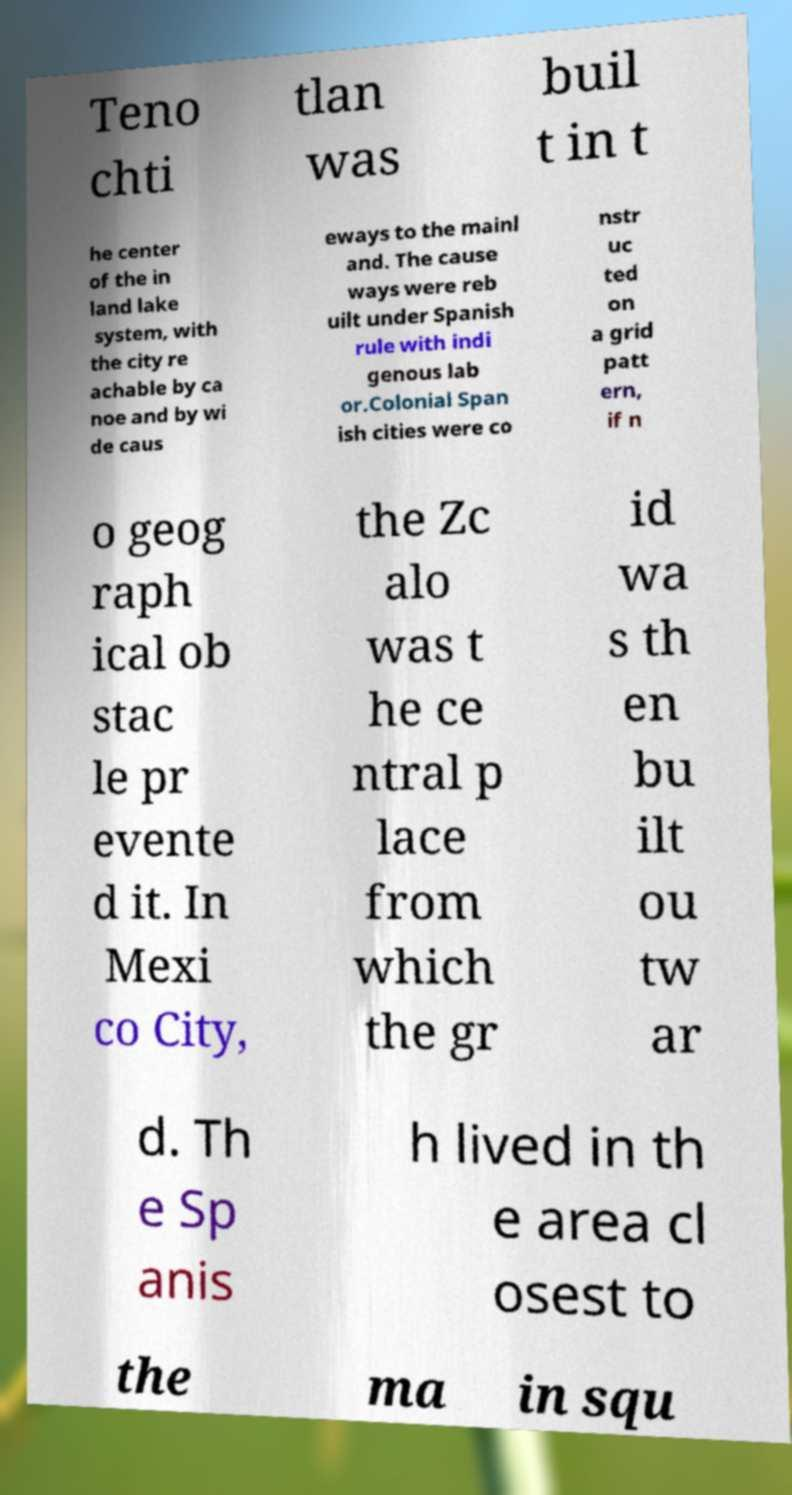Please read and relay the text visible in this image. What does it say? Teno chti tlan was buil t in t he center of the in land lake system, with the city re achable by ca noe and by wi de caus eways to the mainl and. The cause ways were reb uilt under Spanish rule with indi genous lab or.Colonial Span ish cities were co nstr uc ted on a grid patt ern, if n o geog raph ical ob stac le pr evente d it. In Mexi co City, the Zc alo was t he ce ntral p lace from which the gr id wa s th en bu ilt ou tw ar d. Th e Sp anis h lived in th e area cl osest to the ma in squ 